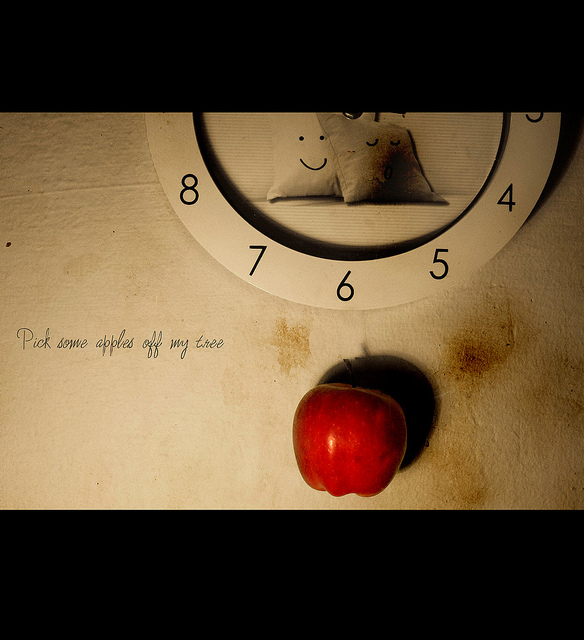Please extract the text content from this image. 8 7 6 5 pick 4 tree MY off apples SOME 